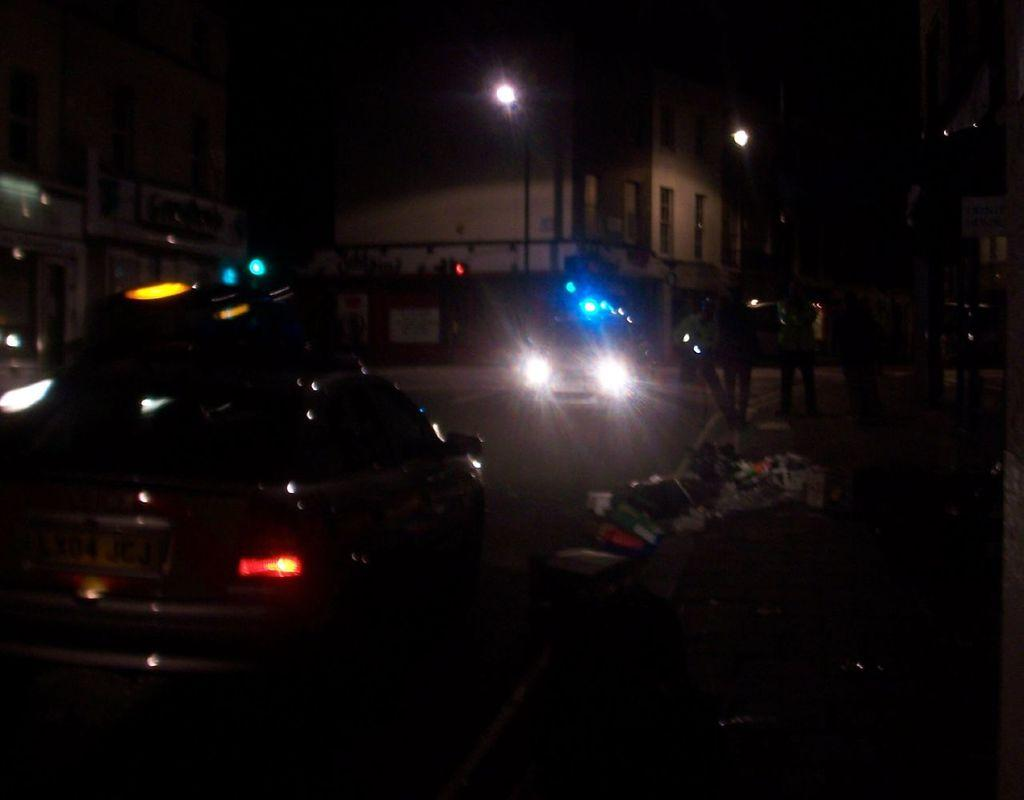What vehicle is located on the left side of the image? There is a car on the left side of the image. What type of structures can be seen at the top side of the image? There are buildings at the top side of the image. What time of day does the image appear to be captured? The image appears to be captured during night time. How does the car distribute its weight during the journey in the image? The car's weight distribution is not visible in the image, as it is a still photograph. 